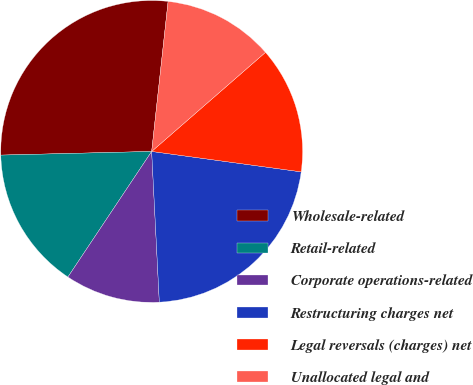Convert chart. <chart><loc_0><loc_0><loc_500><loc_500><pie_chart><fcel>Wholesale-related<fcel>Retail-related<fcel>Corporate operations-related<fcel>Restructuring charges net<fcel>Legal reversals (charges) net<fcel>Unallocated legal and<nl><fcel>27.12%<fcel>15.25%<fcel>10.17%<fcel>22.03%<fcel>13.56%<fcel>11.86%<nl></chart> 